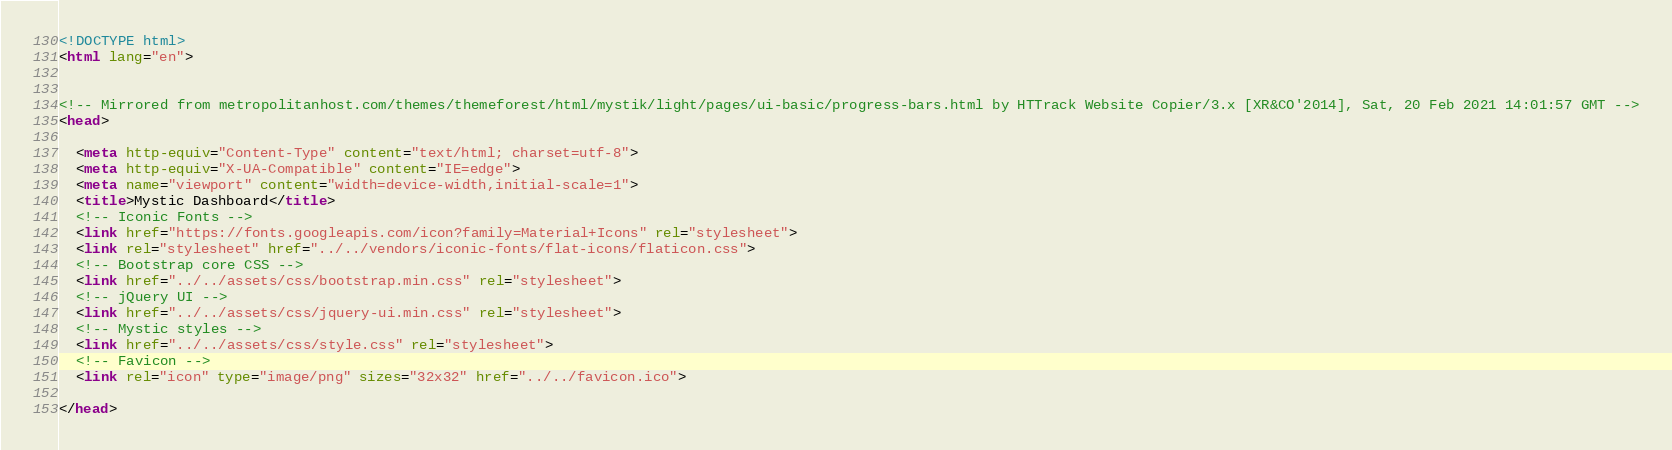<code> <loc_0><loc_0><loc_500><loc_500><_HTML_><!DOCTYPE html>
<html lang="en">


<!-- Mirrored from metropolitanhost.com/themes/themeforest/html/mystik/light/pages/ui-basic/progress-bars.html by HTTrack Website Copier/3.x [XR&CO'2014], Sat, 20 Feb 2021 14:01:57 GMT -->
<head>

  <meta http-equiv="Content-Type" content="text/html; charset=utf-8">
  <meta http-equiv="X-UA-Compatible" content="IE=edge">
  <meta name="viewport" content="width=device-width,initial-scale=1">
  <title>Mystic Dashboard</title>
  <!-- Iconic Fonts -->
  <link href="https://fonts.googleapis.com/icon?family=Material+Icons" rel="stylesheet">
  <link rel="stylesheet" href="../../vendors/iconic-fonts/flat-icons/flaticon.css">
  <!-- Bootstrap core CSS -->
  <link href="../../assets/css/bootstrap.min.css" rel="stylesheet">
  <!-- jQuery UI -->
  <link href="../../assets/css/jquery-ui.min.css" rel="stylesheet">
  <!-- Mystic styles -->
  <link href="../../assets/css/style.css" rel="stylesheet">
  <!-- Favicon -->
  <link rel="icon" type="image/png" sizes="32x32" href="../../favicon.ico">

</head>
</code> 